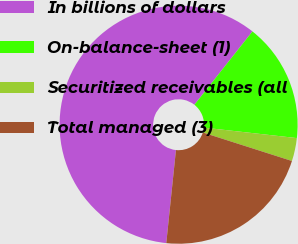Convert chart. <chart><loc_0><loc_0><loc_500><loc_500><pie_chart><fcel>In billions of dollars<fcel>On-balance-sheet (1)<fcel>Securitized receivables (all<fcel>Total managed (3)<nl><fcel>59.01%<fcel>16.13%<fcel>3.14%<fcel>21.72%<nl></chart> 